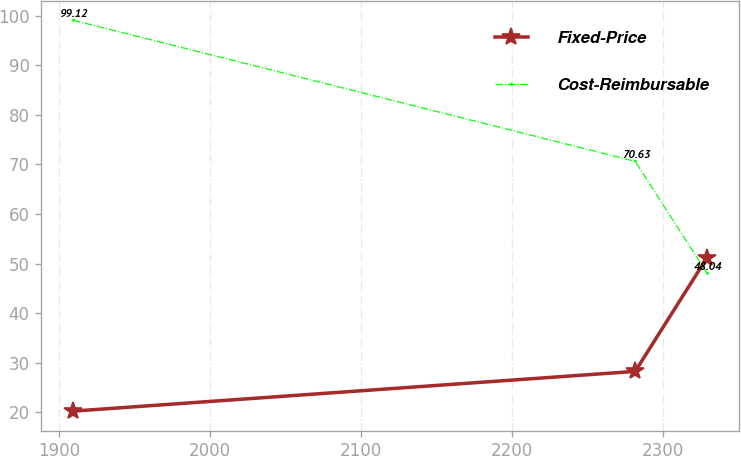<chart> <loc_0><loc_0><loc_500><loc_500><line_chart><ecel><fcel>Fixed-Price<fcel>Cost-Reimbursable<nl><fcel>1909.3<fcel>20.23<fcel>99.12<nl><fcel>2281.49<fcel>28.25<fcel>70.63<nl><fcel>2329.07<fcel>51.21<fcel>48.04<nl></chart> 